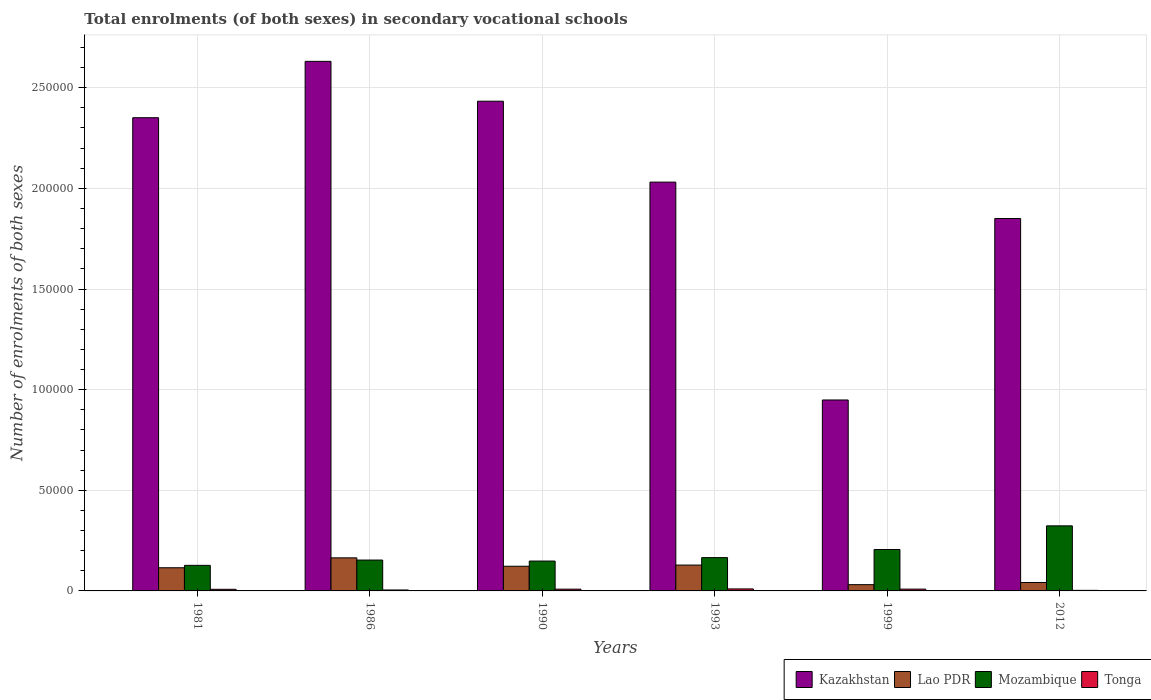Are the number of bars per tick equal to the number of legend labels?
Ensure brevity in your answer.  Yes. What is the number of enrolments in secondary schools in Kazakhstan in 1986?
Ensure brevity in your answer.  2.63e+05. Across all years, what is the maximum number of enrolments in secondary schools in Mozambique?
Give a very brief answer. 3.23e+04. Across all years, what is the minimum number of enrolments in secondary schools in Tonga?
Provide a succinct answer. 281. In which year was the number of enrolments in secondary schools in Kazakhstan maximum?
Make the answer very short. 1986. In which year was the number of enrolments in secondary schools in Tonga minimum?
Make the answer very short. 2012. What is the total number of enrolments in secondary schools in Mozambique in the graph?
Ensure brevity in your answer.  1.12e+05. What is the difference between the number of enrolments in secondary schools in Lao PDR in 1981 and that in 1993?
Ensure brevity in your answer.  -1333. What is the difference between the number of enrolments in secondary schools in Kazakhstan in 1986 and the number of enrolments in secondary schools in Tonga in 2012?
Your answer should be compact. 2.63e+05. What is the average number of enrolments in secondary schools in Lao PDR per year?
Your response must be concise. 1.01e+04. In the year 1981, what is the difference between the number of enrolments in secondary schools in Mozambique and number of enrolments in secondary schools in Lao PDR?
Give a very brief answer. 1194. What is the ratio of the number of enrolments in secondary schools in Kazakhstan in 1986 to that in 2012?
Give a very brief answer. 1.42. Is the number of enrolments in secondary schools in Mozambique in 1990 less than that in 1999?
Your answer should be very brief. Yes. Is the difference between the number of enrolments in secondary schools in Mozambique in 1990 and 1999 greater than the difference between the number of enrolments in secondary schools in Lao PDR in 1990 and 1999?
Offer a very short reply. No. What is the difference between the highest and the second highest number of enrolments in secondary schools in Kazakhstan?
Provide a succinct answer. 1.98e+04. What is the difference between the highest and the lowest number of enrolments in secondary schools in Mozambique?
Your response must be concise. 1.96e+04. What does the 2nd bar from the left in 1986 represents?
Provide a short and direct response. Lao PDR. What does the 2nd bar from the right in 2012 represents?
Offer a very short reply. Mozambique. Are all the bars in the graph horizontal?
Offer a very short reply. No. How many years are there in the graph?
Keep it short and to the point. 6. Does the graph contain any zero values?
Your response must be concise. No. Does the graph contain grids?
Your answer should be very brief. Yes. Where does the legend appear in the graph?
Offer a very short reply. Bottom right. How are the legend labels stacked?
Provide a short and direct response. Horizontal. What is the title of the graph?
Give a very brief answer. Total enrolments (of both sexes) in secondary vocational schools. What is the label or title of the Y-axis?
Make the answer very short. Number of enrolments of both sexes. What is the Number of enrolments of both sexes of Kazakhstan in 1981?
Your answer should be very brief. 2.35e+05. What is the Number of enrolments of both sexes of Lao PDR in 1981?
Provide a succinct answer. 1.15e+04. What is the Number of enrolments of both sexes in Mozambique in 1981?
Your answer should be compact. 1.27e+04. What is the Number of enrolments of both sexes of Tonga in 1981?
Your answer should be compact. 806. What is the Number of enrolments of both sexes of Kazakhstan in 1986?
Ensure brevity in your answer.  2.63e+05. What is the Number of enrolments of both sexes of Lao PDR in 1986?
Your response must be concise. 1.64e+04. What is the Number of enrolments of both sexes in Mozambique in 1986?
Your response must be concise. 1.53e+04. What is the Number of enrolments of both sexes of Tonga in 1986?
Provide a succinct answer. 467. What is the Number of enrolments of both sexes in Kazakhstan in 1990?
Give a very brief answer. 2.43e+05. What is the Number of enrolments of both sexes of Lao PDR in 1990?
Offer a terse response. 1.23e+04. What is the Number of enrolments of both sexes in Mozambique in 1990?
Your answer should be compact. 1.48e+04. What is the Number of enrolments of both sexes in Tonga in 1990?
Your answer should be very brief. 872. What is the Number of enrolments of both sexes of Kazakhstan in 1993?
Provide a succinct answer. 2.03e+05. What is the Number of enrolments of both sexes of Lao PDR in 1993?
Make the answer very short. 1.28e+04. What is the Number of enrolments of both sexes of Mozambique in 1993?
Your answer should be compact. 1.65e+04. What is the Number of enrolments of both sexes in Tonga in 1993?
Make the answer very short. 997. What is the Number of enrolments of both sexes of Kazakhstan in 1999?
Offer a terse response. 9.49e+04. What is the Number of enrolments of both sexes in Lao PDR in 1999?
Keep it short and to the point. 3110. What is the Number of enrolments of both sexes of Mozambique in 1999?
Make the answer very short. 2.06e+04. What is the Number of enrolments of both sexes of Tonga in 1999?
Offer a very short reply. 896. What is the Number of enrolments of both sexes of Kazakhstan in 2012?
Provide a succinct answer. 1.85e+05. What is the Number of enrolments of both sexes of Lao PDR in 2012?
Make the answer very short. 4190. What is the Number of enrolments of both sexes in Mozambique in 2012?
Offer a very short reply. 3.23e+04. What is the Number of enrolments of both sexes of Tonga in 2012?
Provide a succinct answer. 281. Across all years, what is the maximum Number of enrolments of both sexes in Kazakhstan?
Provide a succinct answer. 2.63e+05. Across all years, what is the maximum Number of enrolments of both sexes of Lao PDR?
Make the answer very short. 1.64e+04. Across all years, what is the maximum Number of enrolments of both sexes of Mozambique?
Provide a succinct answer. 3.23e+04. Across all years, what is the maximum Number of enrolments of both sexes of Tonga?
Offer a terse response. 997. Across all years, what is the minimum Number of enrolments of both sexes in Kazakhstan?
Keep it short and to the point. 9.49e+04. Across all years, what is the minimum Number of enrolments of both sexes of Lao PDR?
Your answer should be very brief. 3110. Across all years, what is the minimum Number of enrolments of both sexes of Mozambique?
Provide a succinct answer. 1.27e+04. Across all years, what is the minimum Number of enrolments of both sexes in Tonga?
Your answer should be very brief. 281. What is the total Number of enrolments of both sexes in Kazakhstan in the graph?
Your answer should be compact. 1.22e+06. What is the total Number of enrolments of both sexes in Lao PDR in the graph?
Your response must be concise. 6.03e+04. What is the total Number of enrolments of both sexes of Mozambique in the graph?
Your answer should be compact. 1.12e+05. What is the total Number of enrolments of both sexes of Tonga in the graph?
Your answer should be very brief. 4319. What is the difference between the Number of enrolments of both sexes in Kazakhstan in 1981 and that in 1986?
Make the answer very short. -2.80e+04. What is the difference between the Number of enrolments of both sexes in Lao PDR in 1981 and that in 1986?
Give a very brief answer. -4923. What is the difference between the Number of enrolments of both sexes of Mozambique in 1981 and that in 1986?
Make the answer very short. -2634. What is the difference between the Number of enrolments of both sexes of Tonga in 1981 and that in 1986?
Offer a very short reply. 339. What is the difference between the Number of enrolments of both sexes of Kazakhstan in 1981 and that in 1990?
Offer a very short reply. -8200. What is the difference between the Number of enrolments of both sexes of Lao PDR in 1981 and that in 1990?
Provide a short and direct response. -752. What is the difference between the Number of enrolments of both sexes in Mozambique in 1981 and that in 1990?
Your answer should be compact. -2132. What is the difference between the Number of enrolments of both sexes in Tonga in 1981 and that in 1990?
Make the answer very short. -66. What is the difference between the Number of enrolments of both sexes of Kazakhstan in 1981 and that in 1993?
Keep it short and to the point. 3.20e+04. What is the difference between the Number of enrolments of both sexes in Lao PDR in 1981 and that in 1993?
Your answer should be very brief. -1333. What is the difference between the Number of enrolments of both sexes in Mozambique in 1981 and that in 1993?
Give a very brief answer. -3842. What is the difference between the Number of enrolments of both sexes in Tonga in 1981 and that in 1993?
Offer a very short reply. -191. What is the difference between the Number of enrolments of both sexes in Kazakhstan in 1981 and that in 1999?
Offer a terse response. 1.40e+05. What is the difference between the Number of enrolments of both sexes in Lao PDR in 1981 and that in 1999?
Make the answer very short. 8400. What is the difference between the Number of enrolments of both sexes in Mozambique in 1981 and that in 1999?
Make the answer very short. -7869. What is the difference between the Number of enrolments of both sexes in Tonga in 1981 and that in 1999?
Your answer should be compact. -90. What is the difference between the Number of enrolments of both sexes in Kazakhstan in 1981 and that in 2012?
Your answer should be compact. 5.01e+04. What is the difference between the Number of enrolments of both sexes of Lao PDR in 1981 and that in 2012?
Your answer should be compact. 7320. What is the difference between the Number of enrolments of both sexes in Mozambique in 1981 and that in 2012?
Your response must be concise. -1.96e+04. What is the difference between the Number of enrolments of both sexes in Tonga in 1981 and that in 2012?
Make the answer very short. 525. What is the difference between the Number of enrolments of both sexes in Kazakhstan in 1986 and that in 1990?
Ensure brevity in your answer.  1.98e+04. What is the difference between the Number of enrolments of both sexes in Lao PDR in 1986 and that in 1990?
Your answer should be very brief. 4171. What is the difference between the Number of enrolments of both sexes in Mozambique in 1986 and that in 1990?
Keep it short and to the point. 502. What is the difference between the Number of enrolments of both sexes of Tonga in 1986 and that in 1990?
Your answer should be compact. -405. What is the difference between the Number of enrolments of both sexes of Lao PDR in 1986 and that in 1993?
Make the answer very short. 3590. What is the difference between the Number of enrolments of both sexes in Mozambique in 1986 and that in 1993?
Offer a terse response. -1208. What is the difference between the Number of enrolments of both sexes in Tonga in 1986 and that in 1993?
Provide a short and direct response. -530. What is the difference between the Number of enrolments of both sexes of Kazakhstan in 1986 and that in 1999?
Your answer should be very brief. 1.68e+05. What is the difference between the Number of enrolments of both sexes in Lao PDR in 1986 and that in 1999?
Your response must be concise. 1.33e+04. What is the difference between the Number of enrolments of both sexes in Mozambique in 1986 and that in 1999?
Your answer should be very brief. -5235. What is the difference between the Number of enrolments of both sexes of Tonga in 1986 and that in 1999?
Keep it short and to the point. -429. What is the difference between the Number of enrolments of both sexes of Kazakhstan in 1986 and that in 2012?
Your answer should be very brief. 7.81e+04. What is the difference between the Number of enrolments of both sexes in Lao PDR in 1986 and that in 2012?
Offer a terse response. 1.22e+04. What is the difference between the Number of enrolments of both sexes in Mozambique in 1986 and that in 2012?
Keep it short and to the point. -1.70e+04. What is the difference between the Number of enrolments of both sexes in Tonga in 1986 and that in 2012?
Give a very brief answer. 186. What is the difference between the Number of enrolments of both sexes in Kazakhstan in 1990 and that in 1993?
Offer a terse response. 4.02e+04. What is the difference between the Number of enrolments of both sexes of Lao PDR in 1990 and that in 1993?
Give a very brief answer. -581. What is the difference between the Number of enrolments of both sexes of Mozambique in 1990 and that in 1993?
Your response must be concise. -1710. What is the difference between the Number of enrolments of both sexes in Tonga in 1990 and that in 1993?
Keep it short and to the point. -125. What is the difference between the Number of enrolments of both sexes in Kazakhstan in 1990 and that in 1999?
Give a very brief answer. 1.48e+05. What is the difference between the Number of enrolments of both sexes of Lao PDR in 1990 and that in 1999?
Your answer should be compact. 9152. What is the difference between the Number of enrolments of both sexes in Mozambique in 1990 and that in 1999?
Make the answer very short. -5737. What is the difference between the Number of enrolments of both sexes of Kazakhstan in 1990 and that in 2012?
Give a very brief answer. 5.83e+04. What is the difference between the Number of enrolments of both sexes in Lao PDR in 1990 and that in 2012?
Provide a succinct answer. 8072. What is the difference between the Number of enrolments of both sexes in Mozambique in 1990 and that in 2012?
Ensure brevity in your answer.  -1.75e+04. What is the difference between the Number of enrolments of both sexes in Tonga in 1990 and that in 2012?
Give a very brief answer. 591. What is the difference between the Number of enrolments of both sexes of Kazakhstan in 1993 and that in 1999?
Make the answer very short. 1.08e+05. What is the difference between the Number of enrolments of both sexes in Lao PDR in 1993 and that in 1999?
Ensure brevity in your answer.  9733. What is the difference between the Number of enrolments of both sexes in Mozambique in 1993 and that in 1999?
Give a very brief answer. -4027. What is the difference between the Number of enrolments of both sexes in Tonga in 1993 and that in 1999?
Give a very brief answer. 101. What is the difference between the Number of enrolments of both sexes of Kazakhstan in 1993 and that in 2012?
Provide a succinct answer. 1.81e+04. What is the difference between the Number of enrolments of both sexes in Lao PDR in 1993 and that in 2012?
Keep it short and to the point. 8653. What is the difference between the Number of enrolments of both sexes of Mozambique in 1993 and that in 2012?
Give a very brief answer. -1.58e+04. What is the difference between the Number of enrolments of both sexes of Tonga in 1993 and that in 2012?
Give a very brief answer. 716. What is the difference between the Number of enrolments of both sexes in Kazakhstan in 1999 and that in 2012?
Keep it short and to the point. -9.02e+04. What is the difference between the Number of enrolments of both sexes in Lao PDR in 1999 and that in 2012?
Provide a short and direct response. -1080. What is the difference between the Number of enrolments of both sexes in Mozambique in 1999 and that in 2012?
Ensure brevity in your answer.  -1.18e+04. What is the difference between the Number of enrolments of both sexes of Tonga in 1999 and that in 2012?
Provide a succinct answer. 615. What is the difference between the Number of enrolments of both sexes in Kazakhstan in 1981 and the Number of enrolments of both sexes in Lao PDR in 1986?
Offer a very short reply. 2.19e+05. What is the difference between the Number of enrolments of both sexes in Kazakhstan in 1981 and the Number of enrolments of both sexes in Mozambique in 1986?
Provide a short and direct response. 2.20e+05. What is the difference between the Number of enrolments of both sexes of Kazakhstan in 1981 and the Number of enrolments of both sexes of Tonga in 1986?
Your answer should be very brief. 2.35e+05. What is the difference between the Number of enrolments of both sexes in Lao PDR in 1981 and the Number of enrolments of both sexes in Mozambique in 1986?
Provide a short and direct response. -3828. What is the difference between the Number of enrolments of both sexes of Lao PDR in 1981 and the Number of enrolments of both sexes of Tonga in 1986?
Provide a succinct answer. 1.10e+04. What is the difference between the Number of enrolments of both sexes of Mozambique in 1981 and the Number of enrolments of both sexes of Tonga in 1986?
Your answer should be compact. 1.22e+04. What is the difference between the Number of enrolments of both sexes in Kazakhstan in 1981 and the Number of enrolments of both sexes in Lao PDR in 1990?
Your answer should be very brief. 2.23e+05. What is the difference between the Number of enrolments of both sexes of Kazakhstan in 1981 and the Number of enrolments of both sexes of Mozambique in 1990?
Your answer should be very brief. 2.20e+05. What is the difference between the Number of enrolments of both sexes in Kazakhstan in 1981 and the Number of enrolments of both sexes in Tonga in 1990?
Provide a succinct answer. 2.34e+05. What is the difference between the Number of enrolments of both sexes in Lao PDR in 1981 and the Number of enrolments of both sexes in Mozambique in 1990?
Provide a short and direct response. -3326. What is the difference between the Number of enrolments of both sexes in Lao PDR in 1981 and the Number of enrolments of both sexes in Tonga in 1990?
Make the answer very short. 1.06e+04. What is the difference between the Number of enrolments of both sexes of Mozambique in 1981 and the Number of enrolments of both sexes of Tonga in 1990?
Offer a very short reply. 1.18e+04. What is the difference between the Number of enrolments of both sexes in Kazakhstan in 1981 and the Number of enrolments of both sexes in Lao PDR in 1993?
Provide a short and direct response. 2.22e+05. What is the difference between the Number of enrolments of both sexes of Kazakhstan in 1981 and the Number of enrolments of both sexes of Mozambique in 1993?
Your response must be concise. 2.19e+05. What is the difference between the Number of enrolments of both sexes in Kazakhstan in 1981 and the Number of enrolments of both sexes in Tonga in 1993?
Offer a terse response. 2.34e+05. What is the difference between the Number of enrolments of both sexes in Lao PDR in 1981 and the Number of enrolments of both sexes in Mozambique in 1993?
Make the answer very short. -5036. What is the difference between the Number of enrolments of both sexes in Lao PDR in 1981 and the Number of enrolments of both sexes in Tonga in 1993?
Your answer should be very brief. 1.05e+04. What is the difference between the Number of enrolments of both sexes of Mozambique in 1981 and the Number of enrolments of both sexes of Tonga in 1993?
Provide a short and direct response. 1.17e+04. What is the difference between the Number of enrolments of both sexes in Kazakhstan in 1981 and the Number of enrolments of both sexes in Lao PDR in 1999?
Keep it short and to the point. 2.32e+05. What is the difference between the Number of enrolments of both sexes in Kazakhstan in 1981 and the Number of enrolments of both sexes in Mozambique in 1999?
Your answer should be very brief. 2.15e+05. What is the difference between the Number of enrolments of both sexes of Kazakhstan in 1981 and the Number of enrolments of both sexes of Tonga in 1999?
Make the answer very short. 2.34e+05. What is the difference between the Number of enrolments of both sexes of Lao PDR in 1981 and the Number of enrolments of both sexes of Mozambique in 1999?
Your answer should be very brief. -9063. What is the difference between the Number of enrolments of both sexes in Lao PDR in 1981 and the Number of enrolments of both sexes in Tonga in 1999?
Make the answer very short. 1.06e+04. What is the difference between the Number of enrolments of both sexes of Mozambique in 1981 and the Number of enrolments of both sexes of Tonga in 1999?
Provide a succinct answer. 1.18e+04. What is the difference between the Number of enrolments of both sexes of Kazakhstan in 1981 and the Number of enrolments of both sexes of Lao PDR in 2012?
Your answer should be compact. 2.31e+05. What is the difference between the Number of enrolments of both sexes of Kazakhstan in 1981 and the Number of enrolments of both sexes of Mozambique in 2012?
Provide a short and direct response. 2.03e+05. What is the difference between the Number of enrolments of both sexes in Kazakhstan in 1981 and the Number of enrolments of both sexes in Tonga in 2012?
Offer a very short reply. 2.35e+05. What is the difference between the Number of enrolments of both sexes in Lao PDR in 1981 and the Number of enrolments of both sexes in Mozambique in 2012?
Make the answer very short. -2.08e+04. What is the difference between the Number of enrolments of both sexes of Lao PDR in 1981 and the Number of enrolments of both sexes of Tonga in 2012?
Provide a succinct answer. 1.12e+04. What is the difference between the Number of enrolments of both sexes in Mozambique in 1981 and the Number of enrolments of both sexes in Tonga in 2012?
Your response must be concise. 1.24e+04. What is the difference between the Number of enrolments of both sexes in Kazakhstan in 1986 and the Number of enrolments of both sexes in Lao PDR in 1990?
Your answer should be compact. 2.51e+05. What is the difference between the Number of enrolments of both sexes in Kazakhstan in 1986 and the Number of enrolments of both sexes in Mozambique in 1990?
Offer a terse response. 2.48e+05. What is the difference between the Number of enrolments of both sexes of Kazakhstan in 1986 and the Number of enrolments of both sexes of Tonga in 1990?
Keep it short and to the point. 2.62e+05. What is the difference between the Number of enrolments of both sexes in Lao PDR in 1986 and the Number of enrolments of both sexes in Mozambique in 1990?
Offer a very short reply. 1597. What is the difference between the Number of enrolments of both sexes of Lao PDR in 1986 and the Number of enrolments of both sexes of Tonga in 1990?
Ensure brevity in your answer.  1.56e+04. What is the difference between the Number of enrolments of both sexes in Mozambique in 1986 and the Number of enrolments of both sexes in Tonga in 1990?
Your answer should be compact. 1.45e+04. What is the difference between the Number of enrolments of both sexes in Kazakhstan in 1986 and the Number of enrolments of both sexes in Lao PDR in 1993?
Offer a very short reply. 2.50e+05. What is the difference between the Number of enrolments of both sexes in Kazakhstan in 1986 and the Number of enrolments of both sexes in Mozambique in 1993?
Your answer should be very brief. 2.47e+05. What is the difference between the Number of enrolments of both sexes in Kazakhstan in 1986 and the Number of enrolments of both sexes in Tonga in 1993?
Ensure brevity in your answer.  2.62e+05. What is the difference between the Number of enrolments of both sexes in Lao PDR in 1986 and the Number of enrolments of both sexes in Mozambique in 1993?
Offer a very short reply. -113. What is the difference between the Number of enrolments of both sexes in Lao PDR in 1986 and the Number of enrolments of both sexes in Tonga in 1993?
Give a very brief answer. 1.54e+04. What is the difference between the Number of enrolments of both sexes in Mozambique in 1986 and the Number of enrolments of both sexes in Tonga in 1993?
Your answer should be very brief. 1.43e+04. What is the difference between the Number of enrolments of both sexes in Kazakhstan in 1986 and the Number of enrolments of both sexes in Lao PDR in 1999?
Offer a very short reply. 2.60e+05. What is the difference between the Number of enrolments of both sexes of Kazakhstan in 1986 and the Number of enrolments of both sexes of Mozambique in 1999?
Make the answer very short. 2.43e+05. What is the difference between the Number of enrolments of both sexes in Kazakhstan in 1986 and the Number of enrolments of both sexes in Tonga in 1999?
Offer a terse response. 2.62e+05. What is the difference between the Number of enrolments of both sexes of Lao PDR in 1986 and the Number of enrolments of both sexes of Mozambique in 1999?
Make the answer very short. -4140. What is the difference between the Number of enrolments of both sexes of Lao PDR in 1986 and the Number of enrolments of both sexes of Tonga in 1999?
Ensure brevity in your answer.  1.55e+04. What is the difference between the Number of enrolments of both sexes in Mozambique in 1986 and the Number of enrolments of both sexes in Tonga in 1999?
Give a very brief answer. 1.44e+04. What is the difference between the Number of enrolments of both sexes of Kazakhstan in 1986 and the Number of enrolments of both sexes of Lao PDR in 2012?
Offer a very short reply. 2.59e+05. What is the difference between the Number of enrolments of both sexes in Kazakhstan in 1986 and the Number of enrolments of both sexes in Mozambique in 2012?
Offer a very short reply. 2.31e+05. What is the difference between the Number of enrolments of both sexes in Kazakhstan in 1986 and the Number of enrolments of both sexes in Tonga in 2012?
Keep it short and to the point. 2.63e+05. What is the difference between the Number of enrolments of both sexes of Lao PDR in 1986 and the Number of enrolments of both sexes of Mozambique in 2012?
Offer a very short reply. -1.59e+04. What is the difference between the Number of enrolments of both sexes in Lao PDR in 1986 and the Number of enrolments of both sexes in Tonga in 2012?
Offer a terse response. 1.62e+04. What is the difference between the Number of enrolments of both sexes in Mozambique in 1986 and the Number of enrolments of both sexes in Tonga in 2012?
Your answer should be compact. 1.51e+04. What is the difference between the Number of enrolments of both sexes in Kazakhstan in 1990 and the Number of enrolments of both sexes in Lao PDR in 1993?
Offer a terse response. 2.30e+05. What is the difference between the Number of enrolments of both sexes in Kazakhstan in 1990 and the Number of enrolments of both sexes in Mozambique in 1993?
Provide a succinct answer. 2.27e+05. What is the difference between the Number of enrolments of both sexes in Kazakhstan in 1990 and the Number of enrolments of both sexes in Tonga in 1993?
Your answer should be very brief. 2.42e+05. What is the difference between the Number of enrolments of both sexes in Lao PDR in 1990 and the Number of enrolments of both sexes in Mozambique in 1993?
Ensure brevity in your answer.  -4284. What is the difference between the Number of enrolments of both sexes in Lao PDR in 1990 and the Number of enrolments of both sexes in Tonga in 1993?
Provide a succinct answer. 1.13e+04. What is the difference between the Number of enrolments of both sexes in Mozambique in 1990 and the Number of enrolments of both sexes in Tonga in 1993?
Keep it short and to the point. 1.38e+04. What is the difference between the Number of enrolments of both sexes of Kazakhstan in 1990 and the Number of enrolments of both sexes of Lao PDR in 1999?
Provide a short and direct response. 2.40e+05. What is the difference between the Number of enrolments of both sexes of Kazakhstan in 1990 and the Number of enrolments of both sexes of Mozambique in 1999?
Make the answer very short. 2.23e+05. What is the difference between the Number of enrolments of both sexes of Kazakhstan in 1990 and the Number of enrolments of both sexes of Tonga in 1999?
Ensure brevity in your answer.  2.42e+05. What is the difference between the Number of enrolments of both sexes in Lao PDR in 1990 and the Number of enrolments of both sexes in Mozambique in 1999?
Offer a terse response. -8311. What is the difference between the Number of enrolments of both sexes of Lao PDR in 1990 and the Number of enrolments of both sexes of Tonga in 1999?
Provide a short and direct response. 1.14e+04. What is the difference between the Number of enrolments of both sexes of Mozambique in 1990 and the Number of enrolments of both sexes of Tonga in 1999?
Keep it short and to the point. 1.39e+04. What is the difference between the Number of enrolments of both sexes in Kazakhstan in 1990 and the Number of enrolments of both sexes in Lao PDR in 2012?
Ensure brevity in your answer.  2.39e+05. What is the difference between the Number of enrolments of both sexes in Kazakhstan in 1990 and the Number of enrolments of both sexes in Mozambique in 2012?
Your answer should be very brief. 2.11e+05. What is the difference between the Number of enrolments of both sexes of Kazakhstan in 1990 and the Number of enrolments of both sexes of Tonga in 2012?
Offer a very short reply. 2.43e+05. What is the difference between the Number of enrolments of both sexes in Lao PDR in 1990 and the Number of enrolments of both sexes in Mozambique in 2012?
Offer a very short reply. -2.01e+04. What is the difference between the Number of enrolments of both sexes in Lao PDR in 1990 and the Number of enrolments of both sexes in Tonga in 2012?
Offer a terse response. 1.20e+04. What is the difference between the Number of enrolments of both sexes of Mozambique in 1990 and the Number of enrolments of both sexes of Tonga in 2012?
Ensure brevity in your answer.  1.46e+04. What is the difference between the Number of enrolments of both sexes in Kazakhstan in 1993 and the Number of enrolments of both sexes in Lao PDR in 1999?
Offer a very short reply. 2.00e+05. What is the difference between the Number of enrolments of both sexes in Kazakhstan in 1993 and the Number of enrolments of both sexes in Mozambique in 1999?
Offer a very short reply. 1.83e+05. What is the difference between the Number of enrolments of both sexes of Kazakhstan in 1993 and the Number of enrolments of both sexes of Tonga in 1999?
Keep it short and to the point. 2.02e+05. What is the difference between the Number of enrolments of both sexes of Lao PDR in 1993 and the Number of enrolments of both sexes of Mozambique in 1999?
Your response must be concise. -7730. What is the difference between the Number of enrolments of both sexes in Lao PDR in 1993 and the Number of enrolments of both sexes in Tonga in 1999?
Your answer should be compact. 1.19e+04. What is the difference between the Number of enrolments of both sexes of Mozambique in 1993 and the Number of enrolments of both sexes of Tonga in 1999?
Your response must be concise. 1.56e+04. What is the difference between the Number of enrolments of both sexes in Kazakhstan in 1993 and the Number of enrolments of both sexes in Lao PDR in 2012?
Your answer should be very brief. 1.99e+05. What is the difference between the Number of enrolments of both sexes of Kazakhstan in 1993 and the Number of enrolments of both sexes of Mozambique in 2012?
Your response must be concise. 1.71e+05. What is the difference between the Number of enrolments of both sexes in Kazakhstan in 1993 and the Number of enrolments of both sexes in Tonga in 2012?
Give a very brief answer. 2.03e+05. What is the difference between the Number of enrolments of both sexes in Lao PDR in 1993 and the Number of enrolments of both sexes in Mozambique in 2012?
Offer a terse response. -1.95e+04. What is the difference between the Number of enrolments of both sexes of Lao PDR in 1993 and the Number of enrolments of both sexes of Tonga in 2012?
Your answer should be compact. 1.26e+04. What is the difference between the Number of enrolments of both sexes in Mozambique in 1993 and the Number of enrolments of both sexes in Tonga in 2012?
Provide a short and direct response. 1.63e+04. What is the difference between the Number of enrolments of both sexes in Kazakhstan in 1999 and the Number of enrolments of both sexes in Lao PDR in 2012?
Your response must be concise. 9.07e+04. What is the difference between the Number of enrolments of both sexes in Kazakhstan in 1999 and the Number of enrolments of both sexes in Mozambique in 2012?
Provide a short and direct response. 6.25e+04. What is the difference between the Number of enrolments of both sexes in Kazakhstan in 1999 and the Number of enrolments of both sexes in Tonga in 2012?
Make the answer very short. 9.46e+04. What is the difference between the Number of enrolments of both sexes in Lao PDR in 1999 and the Number of enrolments of both sexes in Mozambique in 2012?
Your answer should be compact. -2.92e+04. What is the difference between the Number of enrolments of both sexes in Lao PDR in 1999 and the Number of enrolments of both sexes in Tonga in 2012?
Offer a very short reply. 2829. What is the difference between the Number of enrolments of both sexes in Mozambique in 1999 and the Number of enrolments of both sexes in Tonga in 2012?
Keep it short and to the point. 2.03e+04. What is the average Number of enrolments of both sexes of Kazakhstan per year?
Offer a terse response. 2.04e+05. What is the average Number of enrolments of both sexes of Lao PDR per year?
Your response must be concise. 1.01e+04. What is the average Number of enrolments of both sexes of Mozambique per year?
Provide a short and direct response. 1.87e+04. What is the average Number of enrolments of both sexes of Tonga per year?
Keep it short and to the point. 719.83. In the year 1981, what is the difference between the Number of enrolments of both sexes of Kazakhstan and Number of enrolments of both sexes of Lao PDR?
Offer a terse response. 2.24e+05. In the year 1981, what is the difference between the Number of enrolments of both sexes of Kazakhstan and Number of enrolments of both sexes of Mozambique?
Give a very brief answer. 2.22e+05. In the year 1981, what is the difference between the Number of enrolments of both sexes in Kazakhstan and Number of enrolments of both sexes in Tonga?
Provide a short and direct response. 2.34e+05. In the year 1981, what is the difference between the Number of enrolments of both sexes of Lao PDR and Number of enrolments of both sexes of Mozambique?
Offer a very short reply. -1194. In the year 1981, what is the difference between the Number of enrolments of both sexes in Lao PDR and Number of enrolments of both sexes in Tonga?
Your answer should be very brief. 1.07e+04. In the year 1981, what is the difference between the Number of enrolments of both sexes in Mozambique and Number of enrolments of both sexes in Tonga?
Make the answer very short. 1.19e+04. In the year 1986, what is the difference between the Number of enrolments of both sexes in Kazakhstan and Number of enrolments of both sexes in Lao PDR?
Offer a terse response. 2.47e+05. In the year 1986, what is the difference between the Number of enrolments of both sexes of Kazakhstan and Number of enrolments of both sexes of Mozambique?
Ensure brevity in your answer.  2.48e+05. In the year 1986, what is the difference between the Number of enrolments of both sexes in Kazakhstan and Number of enrolments of both sexes in Tonga?
Your answer should be compact. 2.63e+05. In the year 1986, what is the difference between the Number of enrolments of both sexes in Lao PDR and Number of enrolments of both sexes in Mozambique?
Provide a short and direct response. 1095. In the year 1986, what is the difference between the Number of enrolments of both sexes of Lao PDR and Number of enrolments of both sexes of Tonga?
Make the answer very short. 1.60e+04. In the year 1986, what is the difference between the Number of enrolments of both sexes in Mozambique and Number of enrolments of both sexes in Tonga?
Your answer should be very brief. 1.49e+04. In the year 1990, what is the difference between the Number of enrolments of both sexes in Kazakhstan and Number of enrolments of both sexes in Lao PDR?
Keep it short and to the point. 2.31e+05. In the year 1990, what is the difference between the Number of enrolments of both sexes of Kazakhstan and Number of enrolments of both sexes of Mozambique?
Your response must be concise. 2.28e+05. In the year 1990, what is the difference between the Number of enrolments of both sexes in Kazakhstan and Number of enrolments of both sexes in Tonga?
Offer a very short reply. 2.42e+05. In the year 1990, what is the difference between the Number of enrolments of both sexes of Lao PDR and Number of enrolments of both sexes of Mozambique?
Offer a terse response. -2574. In the year 1990, what is the difference between the Number of enrolments of both sexes in Lao PDR and Number of enrolments of both sexes in Tonga?
Keep it short and to the point. 1.14e+04. In the year 1990, what is the difference between the Number of enrolments of both sexes of Mozambique and Number of enrolments of both sexes of Tonga?
Your response must be concise. 1.40e+04. In the year 1993, what is the difference between the Number of enrolments of both sexes in Kazakhstan and Number of enrolments of both sexes in Lao PDR?
Offer a terse response. 1.90e+05. In the year 1993, what is the difference between the Number of enrolments of both sexes of Kazakhstan and Number of enrolments of both sexes of Mozambique?
Offer a very short reply. 1.87e+05. In the year 1993, what is the difference between the Number of enrolments of both sexes in Kazakhstan and Number of enrolments of both sexes in Tonga?
Make the answer very short. 2.02e+05. In the year 1993, what is the difference between the Number of enrolments of both sexes in Lao PDR and Number of enrolments of both sexes in Mozambique?
Offer a very short reply. -3703. In the year 1993, what is the difference between the Number of enrolments of both sexes in Lao PDR and Number of enrolments of both sexes in Tonga?
Provide a short and direct response. 1.18e+04. In the year 1993, what is the difference between the Number of enrolments of both sexes of Mozambique and Number of enrolments of both sexes of Tonga?
Give a very brief answer. 1.55e+04. In the year 1999, what is the difference between the Number of enrolments of both sexes in Kazakhstan and Number of enrolments of both sexes in Lao PDR?
Keep it short and to the point. 9.18e+04. In the year 1999, what is the difference between the Number of enrolments of both sexes in Kazakhstan and Number of enrolments of both sexes in Mozambique?
Provide a short and direct response. 7.43e+04. In the year 1999, what is the difference between the Number of enrolments of both sexes of Kazakhstan and Number of enrolments of both sexes of Tonga?
Give a very brief answer. 9.40e+04. In the year 1999, what is the difference between the Number of enrolments of both sexes in Lao PDR and Number of enrolments of both sexes in Mozambique?
Keep it short and to the point. -1.75e+04. In the year 1999, what is the difference between the Number of enrolments of both sexes in Lao PDR and Number of enrolments of both sexes in Tonga?
Make the answer very short. 2214. In the year 1999, what is the difference between the Number of enrolments of both sexes in Mozambique and Number of enrolments of both sexes in Tonga?
Offer a terse response. 1.97e+04. In the year 2012, what is the difference between the Number of enrolments of both sexes of Kazakhstan and Number of enrolments of both sexes of Lao PDR?
Provide a short and direct response. 1.81e+05. In the year 2012, what is the difference between the Number of enrolments of both sexes of Kazakhstan and Number of enrolments of both sexes of Mozambique?
Keep it short and to the point. 1.53e+05. In the year 2012, what is the difference between the Number of enrolments of both sexes of Kazakhstan and Number of enrolments of both sexes of Tonga?
Make the answer very short. 1.85e+05. In the year 2012, what is the difference between the Number of enrolments of both sexes in Lao PDR and Number of enrolments of both sexes in Mozambique?
Provide a short and direct response. -2.81e+04. In the year 2012, what is the difference between the Number of enrolments of both sexes in Lao PDR and Number of enrolments of both sexes in Tonga?
Give a very brief answer. 3909. In the year 2012, what is the difference between the Number of enrolments of both sexes in Mozambique and Number of enrolments of both sexes in Tonga?
Ensure brevity in your answer.  3.20e+04. What is the ratio of the Number of enrolments of both sexes in Kazakhstan in 1981 to that in 1986?
Offer a very short reply. 0.89. What is the ratio of the Number of enrolments of both sexes of Lao PDR in 1981 to that in 1986?
Provide a short and direct response. 0.7. What is the ratio of the Number of enrolments of both sexes in Mozambique in 1981 to that in 1986?
Offer a very short reply. 0.83. What is the ratio of the Number of enrolments of both sexes of Tonga in 1981 to that in 1986?
Your answer should be very brief. 1.73. What is the ratio of the Number of enrolments of both sexes of Kazakhstan in 1981 to that in 1990?
Your response must be concise. 0.97. What is the ratio of the Number of enrolments of both sexes of Lao PDR in 1981 to that in 1990?
Keep it short and to the point. 0.94. What is the ratio of the Number of enrolments of both sexes in Mozambique in 1981 to that in 1990?
Your answer should be compact. 0.86. What is the ratio of the Number of enrolments of both sexes of Tonga in 1981 to that in 1990?
Offer a very short reply. 0.92. What is the ratio of the Number of enrolments of both sexes in Kazakhstan in 1981 to that in 1993?
Offer a terse response. 1.16. What is the ratio of the Number of enrolments of both sexes in Lao PDR in 1981 to that in 1993?
Your answer should be very brief. 0.9. What is the ratio of the Number of enrolments of both sexes in Mozambique in 1981 to that in 1993?
Offer a terse response. 0.77. What is the ratio of the Number of enrolments of both sexes of Tonga in 1981 to that in 1993?
Offer a terse response. 0.81. What is the ratio of the Number of enrolments of both sexes of Kazakhstan in 1981 to that in 1999?
Offer a very short reply. 2.48. What is the ratio of the Number of enrolments of both sexes of Lao PDR in 1981 to that in 1999?
Give a very brief answer. 3.7. What is the ratio of the Number of enrolments of both sexes of Mozambique in 1981 to that in 1999?
Offer a terse response. 0.62. What is the ratio of the Number of enrolments of both sexes in Tonga in 1981 to that in 1999?
Offer a very short reply. 0.9. What is the ratio of the Number of enrolments of both sexes in Kazakhstan in 1981 to that in 2012?
Keep it short and to the point. 1.27. What is the ratio of the Number of enrolments of both sexes of Lao PDR in 1981 to that in 2012?
Provide a short and direct response. 2.75. What is the ratio of the Number of enrolments of both sexes in Mozambique in 1981 to that in 2012?
Your response must be concise. 0.39. What is the ratio of the Number of enrolments of both sexes of Tonga in 1981 to that in 2012?
Offer a terse response. 2.87. What is the ratio of the Number of enrolments of both sexes of Kazakhstan in 1986 to that in 1990?
Offer a very short reply. 1.08. What is the ratio of the Number of enrolments of both sexes of Lao PDR in 1986 to that in 1990?
Ensure brevity in your answer.  1.34. What is the ratio of the Number of enrolments of both sexes of Mozambique in 1986 to that in 1990?
Give a very brief answer. 1.03. What is the ratio of the Number of enrolments of both sexes of Tonga in 1986 to that in 1990?
Make the answer very short. 0.54. What is the ratio of the Number of enrolments of both sexes of Kazakhstan in 1986 to that in 1993?
Your answer should be very brief. 1.3. What is the ratio of the Number of enrolments of both sexes in Lao PDR in 1986 to that in 1993?
Provide a short and direct response. 1.28. What is the ratio of the Number of enrolments of both sexes of Mozambique in 1986 to that in 1993?
Offer a very short reply. 0.93. What is the ratio of the Number of enrolments of both sexes in Tonga in 1986 to that in 1993?
Give a very brief answer. 0.47. What is the ratio of the Number of enrolments of both sexes of Kazakhstan in 1986 to that in 1999?
Your response must be concise. 2.77. What is the ratio of the Number of enrolments of both sexes of Lao PDR in 1986 to that in 1999?
Offer a terse response. 5.28. What is the ratio of the Number of enrolments of both sexes of Mozambique in 1986 to that in 1999?
Make the answer very short. 0.75. What is the ratio of the Number of enrolments of both sexes in Tonga in 1986 to that in 1999?
Your response must be concise. 0.52. What is the ratio of the Number of enrolments of both sexes in Kazakhstan in 1986 to that in 2012?
Give a very brief answer. 1.42. What is the ratio of the Number of enrolments of both sexes in Lao PDR in 1986 to that in 2012?
Provide a short and direct response. 3.92. What is the ratio of the Number of enrolments of both sexes in Mozambique in 1986 to that in 2012?
Give a very brief answer. 0.47. What is the ratio of the Number of enrolments of both sexes of Tonga in 1986 to that in 2012?
Give a very brief answer. 1.66. What is the ratio of the Number of enrolments of both sexes of Kazakhstan in 1990 to that in 1993?
Give a very brief answer. 1.2. What is the ratio of the Number of enrolments of both sexes in Lao PDR in 1990 to that in 1993?
Offer a terse response. 0.95. What is the ratio of the Number of enrolments of both sexes in Mozambique in 1990 to that in 1993?
Provide a succinct answer. 0.9. What is the ratio of the Number of enrolments of both sexes of Tonga in 1990 to that in 1993?
Offer a terse response. 0.87. What is the ratio of the Number of enrolments of both sexes of Kazakhstan in 1990 to that in 1999?
Offer a very short reply. 2.56. What is the ratio of the Number of enrolments of both sexes of Lao PDR in 1990 to that in 1999?
Your answer should be very brief. 3.94. What is the ratio of the Number of enrolments of both sexes of Mozambique in 1990 to that in 1999?
Offer a very short reply. 0.72. What is the ratio of the Number of enrolments of both sexes of Tonga in 1990 to that in 1999?
Your answer should be very brief. 0.97. What is the ratio of the Number of enrolments of both sexes in Kazakhstan in 1990 to that in 2012?
Provide a short and direct response. 1.31. What is the ratio of the Number of enrolments of both sexes in Lao PDR in 1990 to that in 2012?
Offer a terse response. 2.93. What is the ratio of the Number of enrolments of both sexes in Mozambique in 1990 to that in 2012?
Make the answer very short. 0.46. What is the ratio of the Number of enrolments of both sexes of Tonga in 1990 to that in 2012?
Offer a very short reply. 3.1. What is the ratio of the Number of enrolments of both sexes of Kazakhstan in 1993 to that in 1999?
Your response must be concise. 2.14. What is the ratio of the Number of enrolments of both sexes in Lao PDR in 1993 to that in 1999?
Make the answer very short. 4.13. What is the ratio of the Number of enrolments of both sexes in Mozambique in 1993 to that in 1999?
Keep it short and to the point. 0.8. What is the ratio of the Number of enrolments of both sexes in Tonga in 1993 to that in 1999?
Your response must be concise. 1.11. What is the ratio of the Number of enrolments of both sexes in Kazakhstan in 1993 to that in 2012?
Your answer should be compact. 1.1. What is the ratio of the Number of enrolments of both sexes in Lao PDR in 1993 to that in 2012?
Ensure brevity in your answer.  3.07. What is the ratio of the Number of enrolments of both sexes in Mozambique in 1993 to that in 2012?
Give a very brief answer. 0.51. What is the ratio of the Number of enrolments of both sexes of Tonga in 1993 to that in 2012?
Provide a short and direct response. 3.55. What is the ratio of the Number of enrolments of both sexes of Kazakhstan in 1999 to that in 2012?
Your answer should be very brief. 0.51. What is the ratio of the Number of enrolments of both sexes of Lao PDR in 1999 to that in 2012?
Keep it short and to the point. 0.74. What is the ratio of the Number of enrolments of both sexes of Mozambique in 1999 to that in 2012?
Ensure brevity in your answer.  0.64. What is the ratio of the Number of enrolments of both sexes in Tonga in 1999 to that in 2012?
Provide a succinct answer. 3.19. What is the difference between the highest and the second highest Number of enrolments of both sexes of Kazakhstan?
Offer a terse response. 1.98e+04. What is the difference between the highest and the second highest Number of enrolments of both sexes of Lao PDR?
Offer a terse response. 3590. What is the difference between the highest and the second highest Number of enrolments of both sexes of Mozambique?
Ensure brevity in your answer.  1.18e+04. What is the difference between the highest and the second highest Number of enrolments of both sexes of Tonga?
Provide a succinct answer. 101. What is the difference between the highest and the lowest Number of enrolments of both sexes of Kazakhstan?
Ensure brevity in your answer.  1.68e+05. What is the difference between the highest and the lowest Number of enrolments of both sexes in Lao PDR?
Provide a short and direct response. 1.33e+04. What is the difference between the highest and the lowest Number of enrolments of both sexes in Mozambique?
Ensure brevity in your answer.  1.96e+04. What is the difference between the highest and the lowest Number of enrolments of both sexes of Tonga?
Your answer should be very brief. 716. 